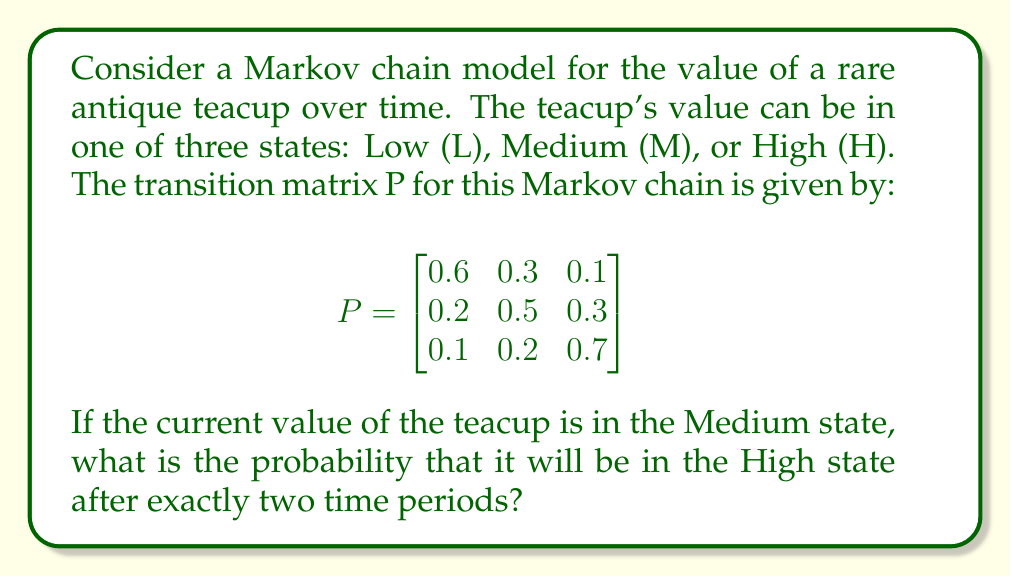Can you answer this question? To solve this problem, we need to use the Chapman-Kolmogorov equations and the properties of Markov chains. We'll follow these steps:

1) First, we need to calculate $P^2$, which represents the two-step transition probabilities. We can do this by multiplying the transition matrix P by itself:

   $$P^2 = P \times P = \begin{bmatrix}
   0.6 & 0.3 & 0.1 \\
   0.2 & 0.5 & 0.3 \\
   0.1 & 0.2 & 0.7
   \end{bmatrix} \times \begin{bmatrix}
   0.6 & 0.3 & 0.1 \\
   0.2 & 0.5 & 0.3 \\
   0.1 & 0.2 & 0.7
   \end{bmatrix}$$

2) Performing the matrix multiplication:

   $$P^2 = \begin{bmatrix}
   0.42 & 0.39 & 0.19 \\
   0.25 & 0.41 & 0.34 \\
   0.17 & 0.31 & 0.52
   \end{bmatrix}$$

3) The question asks for the probability of moving from the Medium state to the High state in two steps. This corresponds to the element in the second row (Medium) and third column (High) of the $P^2$ matrix.

4) From the $P^2$ matrix, we can see that this probability is 0.34 or 34%.

Therefore, the probability that the teacup's value will be in the High state after exactly two time periods, given that it's currently in the Medium state, is 0.34 or 34%.
Answer: 0.34 